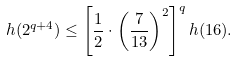Convert formula to latex. <formula><loc_0><loc_0><loc_500><loc_500>h ( 2 ^ { q + 4 } ) \leq \left [ \frac { 1 } { 2 } \cdot \left ( \frac { 7 } { 1 3 } \right ) ^ { 2 } \right ] ^ { q } h ( 1 6 ) .</formula> 